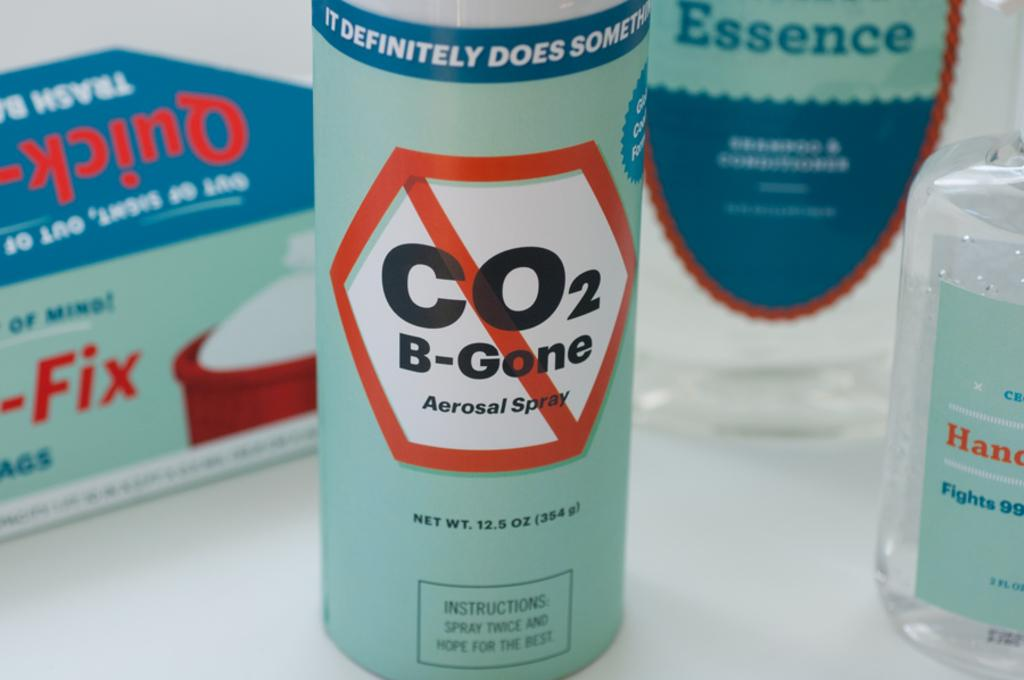<image>
Share a concise interpretation of the image provided. A can of CO2 B-Gone says it definitely does something. 